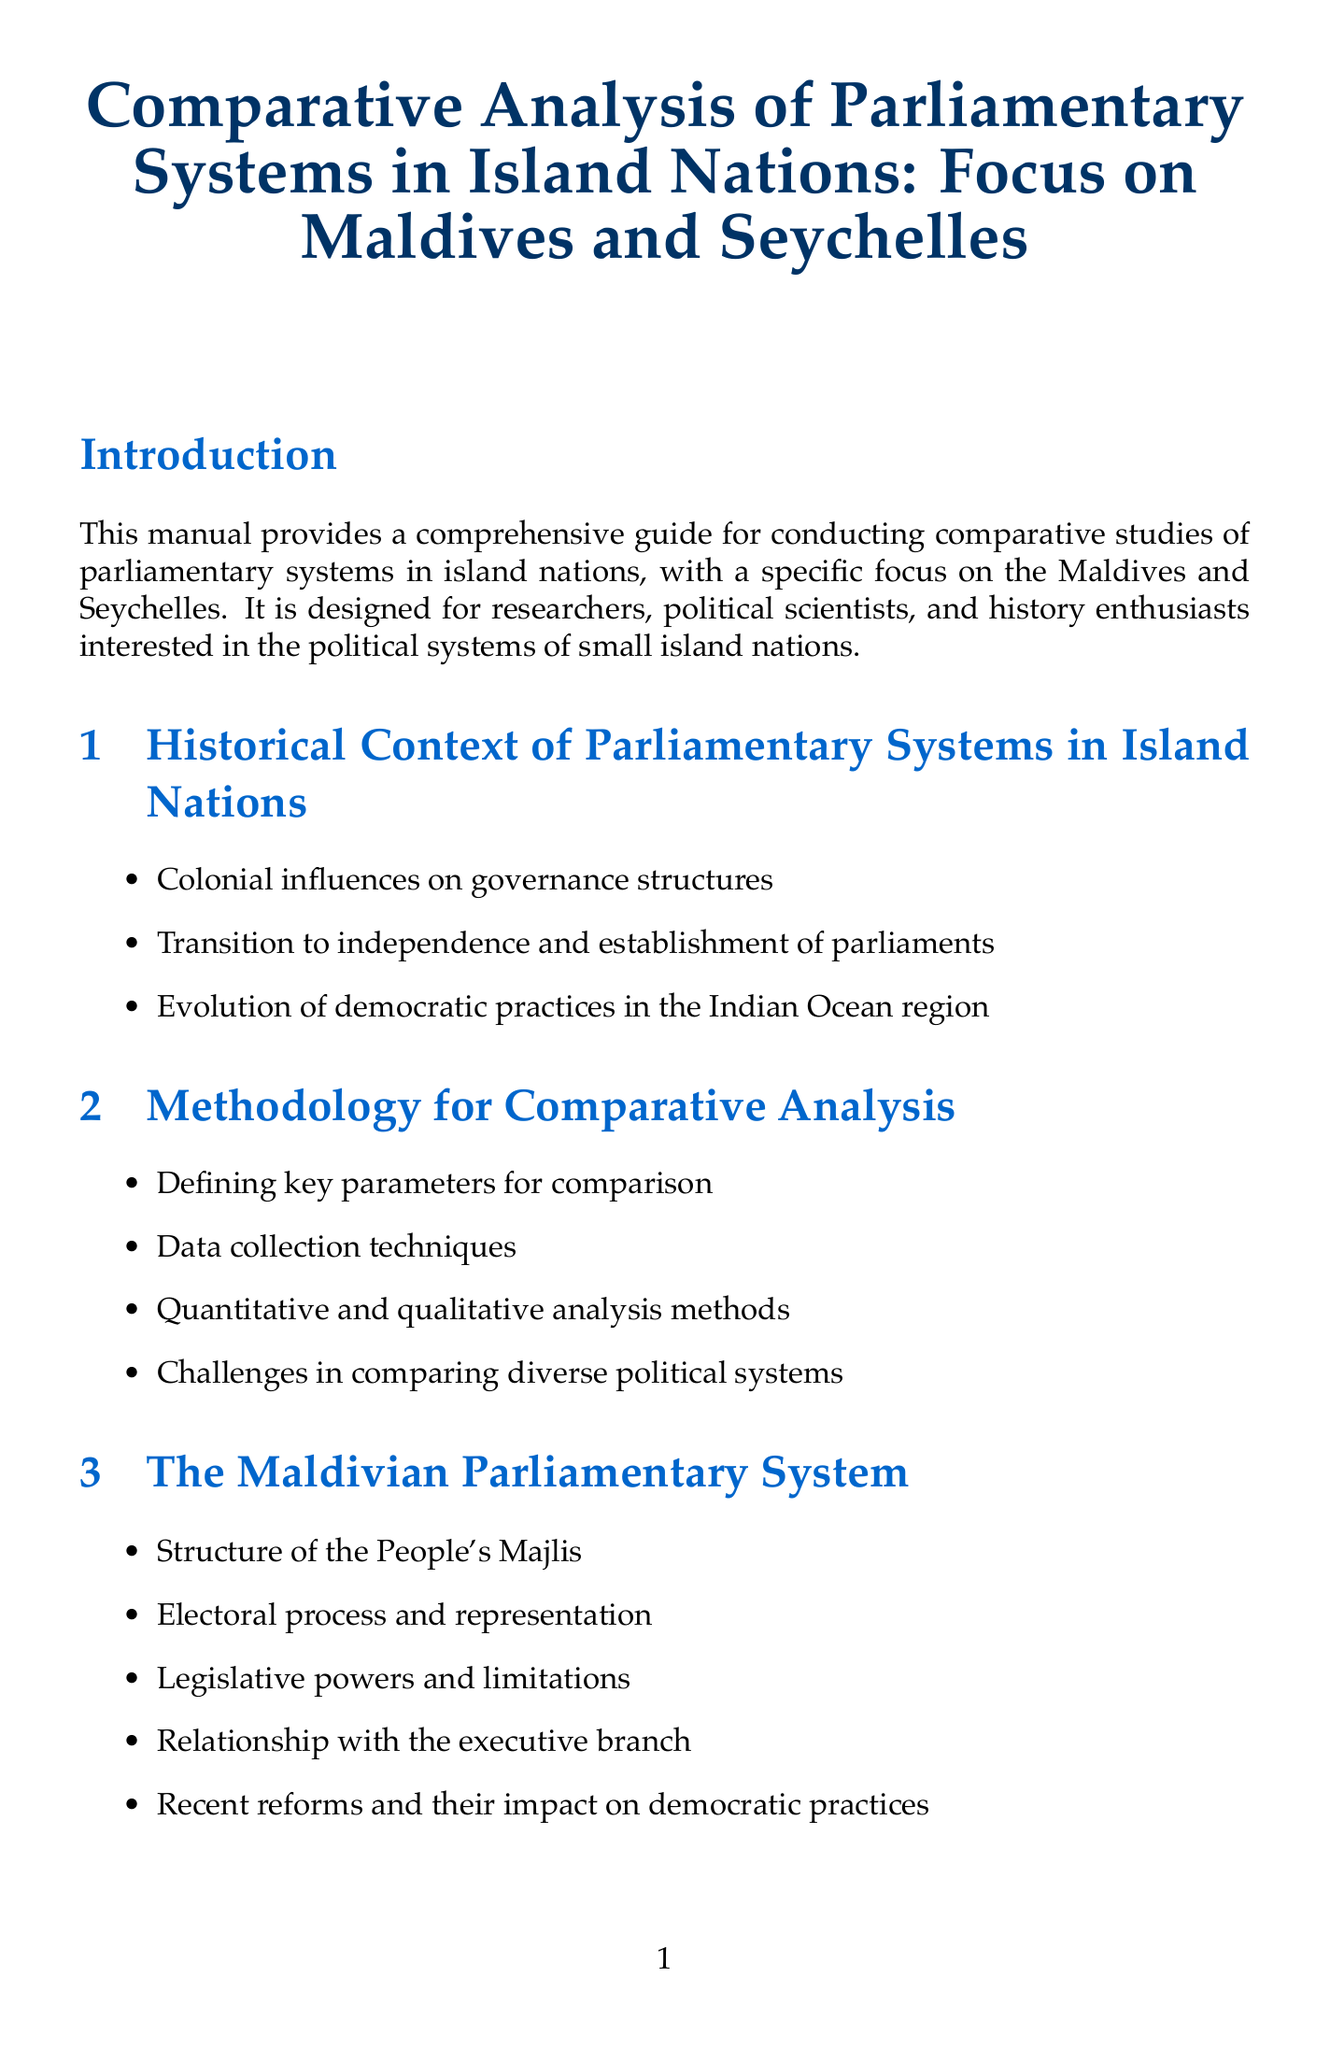What is the title of the manual? The title of the manual as stated in the document is prominently displayed at the beginning.
Answer: Comparative Analysis of Parliamentary Systems in Island Nations: Focus on Maldives and Seychelles Who is the target audience for the manual? The target audience is mentioned in the introduction section of the document.
Answer: Researchers, political scientists, and history enthusiasts Which chapter focuses on the Maldivian parliamentary system? The chapters are organized with specific topics, and the relevant chapter is clearly titled.
Answer: The Maldivian Parliamentary System What are two data collection techniques mentioned in the methodology chapter? The methodology chapter outlines various data collection techniques to support the analysis.
Answer: Primary sources, interviews What is one indicator of democratic health listed in the assessing democratic practices chapter? This chapter provides various indicators that gauge the democratic health of the systems being studied.
Answer: Freedom House Index What significant event does the timeline of democratic milestones cover? The appendices mention timelines of important historical events in the context of democracy.
Answer: Democratic developments in Maldives and Seychelles What electoral system is used in Seychelles? The information about electoral systems is discussed in the section on the Seychellois parliamentary system.
Answer: Mixed electoral system: first-past-the-post and proportional representation What type of reforms has occurred in the Maldivian system recently? Recent reforms are specifically mentioned in the chapter about the Maldivian parliamentary system.
Answer: Recent reforms and their impact on democratic practices Name one resource listed for research. The research resources section names various organizations and databases that can be utilized for further investigation.
Answer: Inter-Parliamentary Union (IPU) database 